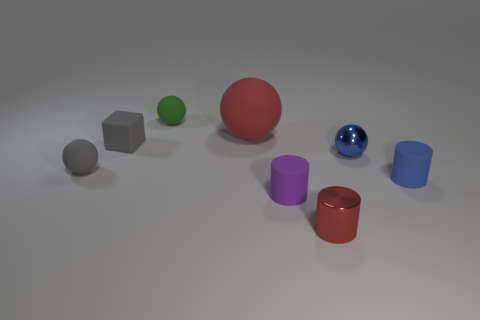Can you tell me which objects appear to have geometric shapes, and how many of each shape are there? Certainly! In the image, I can identify several geometric shapes: There are three spheres, one is red, one is blue, and one is green. Two of the objects are cubes, one gray and one red. Lastly, there are two cylinders, one purple and one blue. 